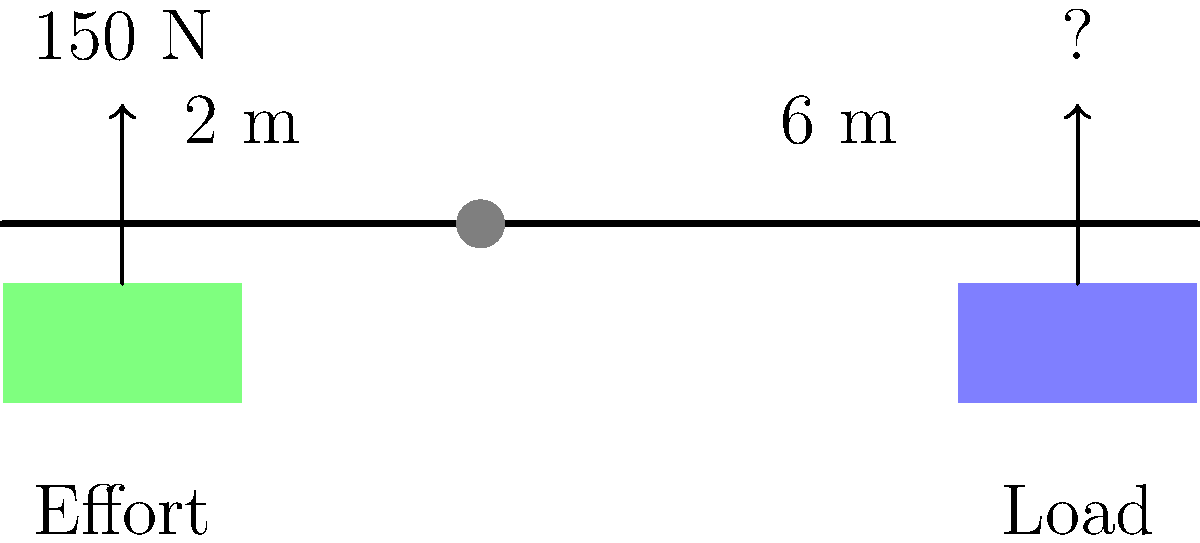In an ancient Egyptian lever system, a worker applies an effort of 150 N at a distance of 2 m from the fulcrum to lift a heavy stone block. If the load is placed 6 m from the fulcrum on the opposite side, what is the maximum weight of the stone block that can be lifted? To solve this problem, we'll use the principle of moments and the concept of mechanical advantage in a lever system:

1) The principle of moments states that for a lever in equilibrium, the sum of clockwise moments equals the sum of counterclockwise moments.

2) Let's define:
   $F_e$ = Effort force = 150 N
   $d_e$ = Distance of effort from fulcrum = 2 m
   $F_l$ = Load force (unknown)
   $d_l$ = Distance of load from fulcrum = 6 m

3) Apply the principle of moments:
   $F_e \times d_e = F_l \times d_l$

4) Substitute the known values:
   $150 \text{ N} \times 2 \text{ m} = F_l \times 6 \text{ m}$

5) Simplify:
   $300 \text{ N·m} = F_l \times 6 \text{ m}$

6) Solve for $F_l$:
   $F_l = \frac{300 \text{ N·m}}{6 \text{ m}} = 50 \text{ N}$

7) The mechanical advantage of this lever system is:
   $MA = \frac{d_l}{d_e} = \frac{6 \text{ m}}{2 \text{ m}} = 3$

   This means the load force is 3 times the effort force, which confirms our calculation.

Therefore, the maximum weight of the stone block that can be lifted is 50 N.
Answer: 50 N 